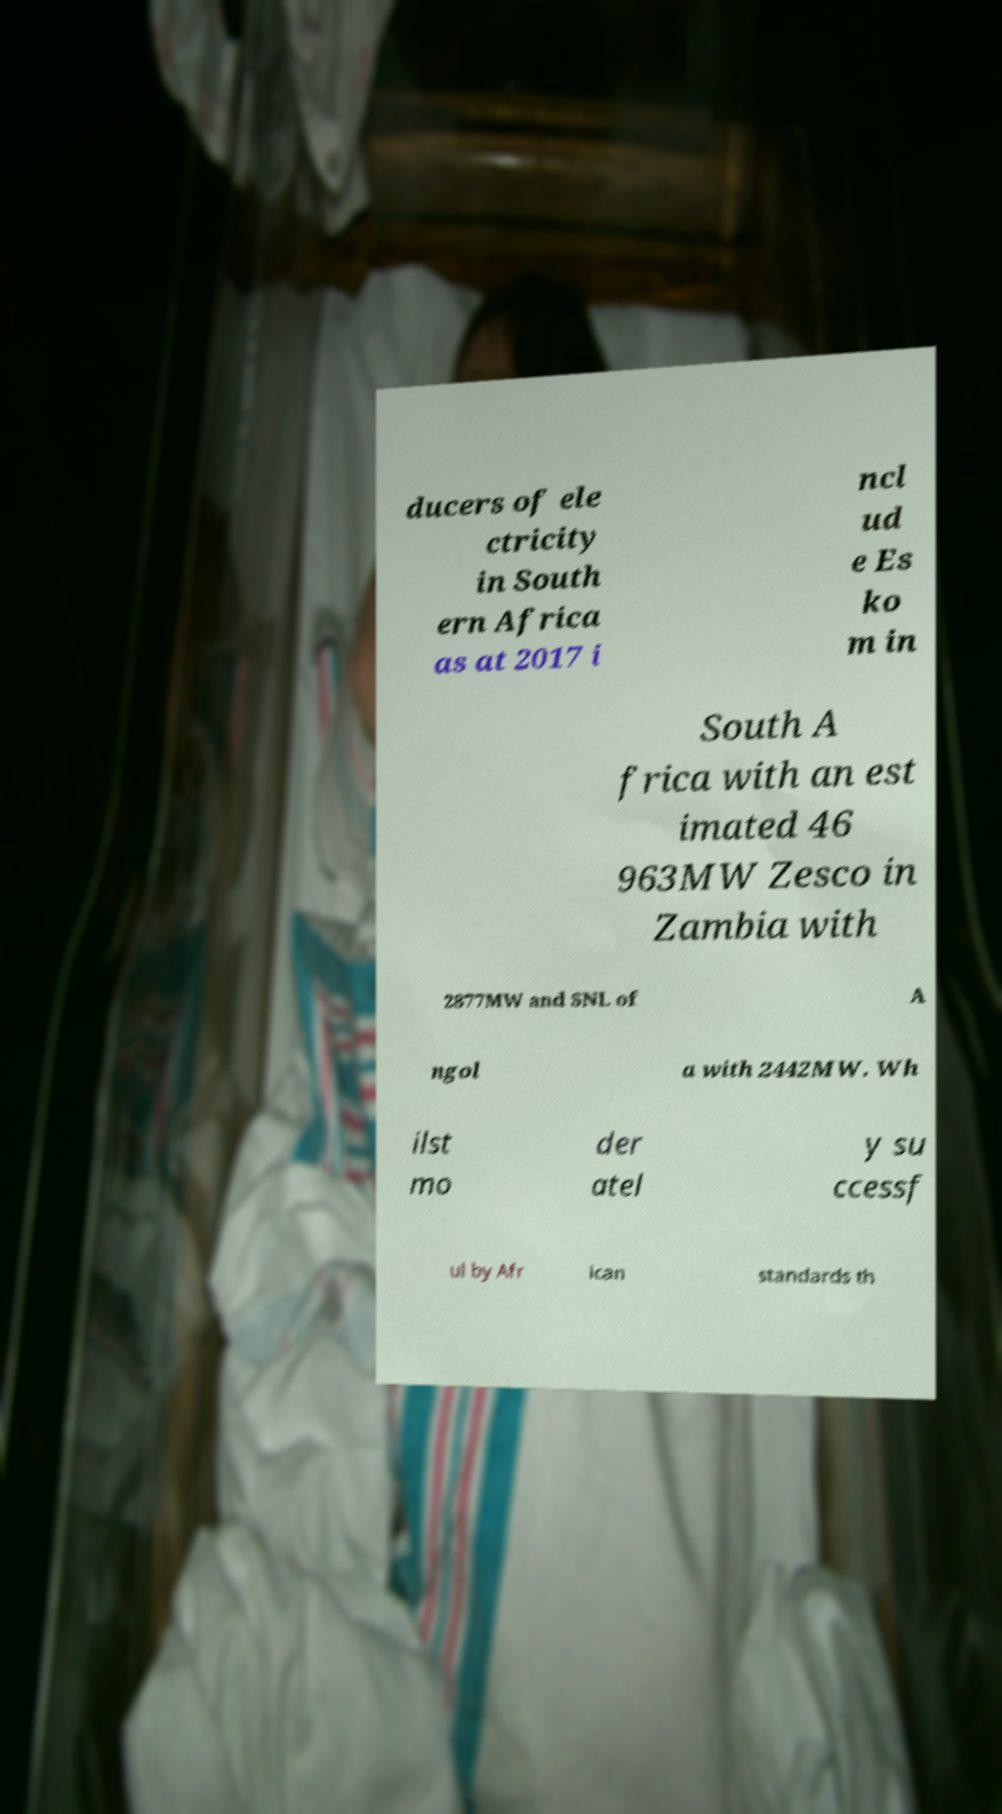There's text embedded in this image that I need extracted. Can you transcribe it verbatim? ducers of ele ctricity in South ern Africa as at 2017 i ncl ud e Es ko m in South A frica with an est imated 46 963MW Zesco in Zambia with 2877MW and SNL of A ngol a with 2442MW. Wh ilst mo der atel y su ccessf ul by Afr ican standards th 